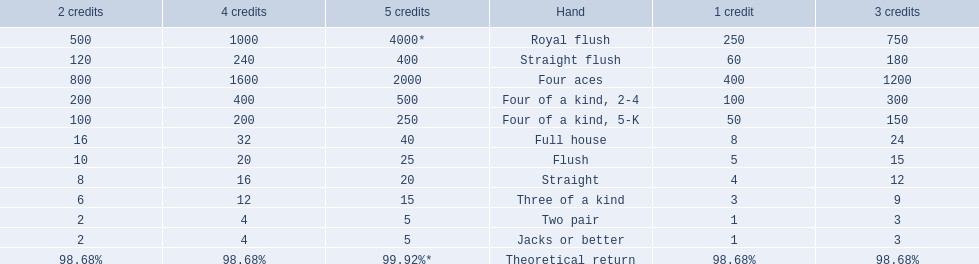What is the values in the 5 credits area? 4000*, 400, 2000, 500, 250, 40, 25, 20, 15, 5, 5. Which of these is for a four of a kind? 500, 250. What is the higher value? 500. What hand is this for Four of a kind, 2-4. 